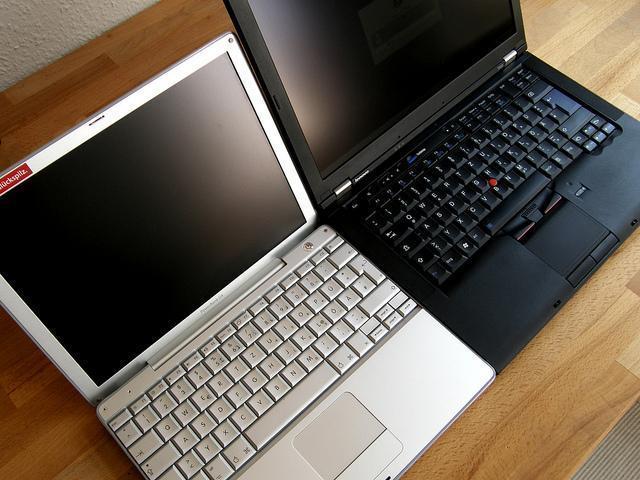How many laptops are on the desk?
Give a very brief answer. 2. How many laptops are in the picture?
Give a very brief answer. 2. How many keyboards are there?
Give a very brief answer. 2. 